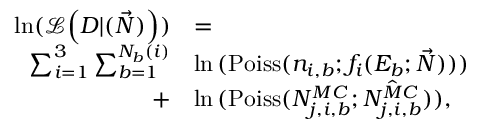Convert formula to latex. <formula><loc_0><loc_0><loc_500><loc_500>\begin{array} { r l } { \ln ( \mathcal { L } \left ( D | ( \vec { N } ) \right ) ) } & { = } \\ { \sum _ { i = 1 } ^ { 3 } \sum _ { b = 1 } ^ { N _ { b } ( i ) } } & { \ln { ( P o i s s ( n _ { i , b } ; f _ { i } ( E _ { b } ; \vec { N } ) ) ) } } \\ { + } & { \ln { ( P o i s s ( N _ { j , i , b } ^ { M C } ; \hat { N _ { j , i , b } ^ { M C } } ) ) } , } \end{array}</formula> 